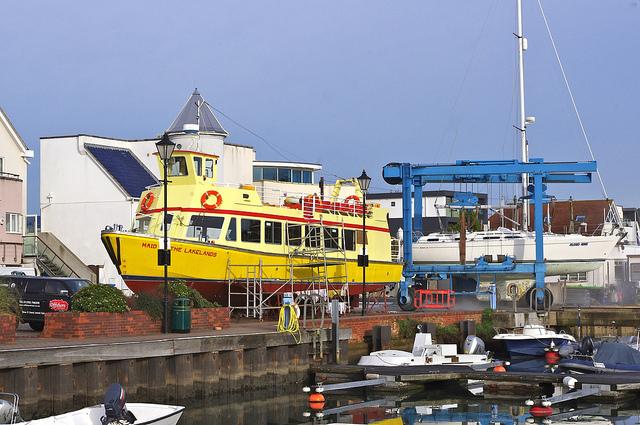Which boat is brighter red and blue?
Answer briefly. Red. What is the yellow object?
Short answer required. Boat. How tall is that far building?
Give a very brief answer. 3 stories. What color is the sign on the side of the van?
Keep it brief. Red. How many lamp posts are there?
Be succinct. 2. What other color is on the yellow boat?
Be succinct. Red. 